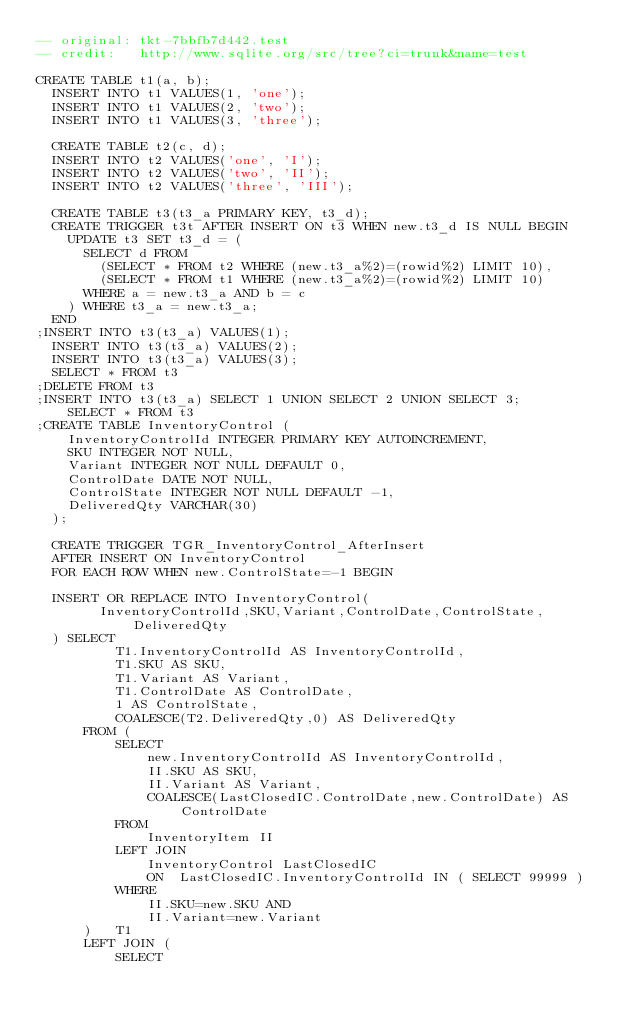<code> <loc_0><loc_0><loc_500><loc_500><_SQL_>-- original: tkt-7bbfb7d442.test
-- credit:   http://www.sqlite.org/src/tree?ci=trunk&name=test

CREATE TABLE t1(a, b);
  INSERT INTO t1 VALUES(1, 'one');
  INSERT INTO t1 VALUES(2, 'two');
  INSERT INTO t1 VALUES(3, 'three');

  CREATE TABLE t2(c, d);
  INSERT INTO t2 VALUES('one', 'I');
  INSERT INTO t2 VALUES('two', 'II');
  INSERT INTO t2 VALUES('three', 'III');

  CREATE TABLE t3(t3_a PRIMARY KEY, t3_d);
  CREATE TRIGGER t3t AFTER INSERT ON t3 WHEN new.t3_d IS NULL BEGIN
    UPDATE t3 SET t3_d = (
      SELECT d FROM 
        (SELECT * FROM t2 WHERE (new.t3_a%2)=(rowid%2) LIMIT 10),
        (SELECT * FROM t1 WHERE (new.t3_a%2)=(rowid%2) LIMIT 10)
      WHERE a = new.t3_a AND b = c
    ) WHERE t3_a = new.t3_a;
  END
;INSERT INTO t3(t3_a) VALUES(1);
  INSERT INTO t3(t3_a) VALUES(2);
  INSERT INTO t3(t3_a) VALUES(3);
  SELECT * FROM t3
;DELETE FROM t3
;INSERT INTO t3(t3_a) SELECT 1 UNION SELECT 2 UNION SELECT 3;
    SELECT * FROM t3
;CREATE TABLE InventoryControl (
    InventoryControlId INTEGER PRIMARY KEY AUTOINCREMENT,
    SKU INTEGER NOT NULL,
    Variant INTEGER NOT NULL DEFAULT 0,
    ControlDate DATE NOT NULL,
    ControlState INTEGER NOT NULL DEFAULT -1,
    DeliveredQty VARCHAR(30)
  );
  
  CREATE TRIGGER TGR_InventoryControl_AfterInsert
  AFTER INSERT ON InventoryControl 
  FOR EACH ROW WHEN new.ControlState=-1 BEGIN 

  INSERT OR REPLACE INTO InventoryControl(
        InventoryControlId,SKU,Variant,ControlDate,ControlState,DeliveredQty
  ) SELECT
          T1.InventoryControlId AS InventoryControlId,
          T1.SKU AS SKU,
          T1.Variant AS Variant,
          T1.ControlDate AS ControlDate,
          1 AS ControlState,
          COALESCE(T2.DeliveredQty,0) AS DeliveredQty
      FROM (
          SELECT
              new.InventoryControlId AS InventoryControlId,
              II.SKU AS SKU,
              II.Variant AS Variant,
              COALESCE(LastClosedIC.ControlDate,new.ControlDate) AS ControlDate
          FROM
              InventoryItem II
          LEFT JOIN
              InventoryControl LastClosedIC
              ON  LastClosedIC.InventoryControlId IN ( SELECT 99999 )
          WHERE
              II.SKU=new.SKU AND
              II.Variant=new.Variant
      )   T1
      LEFT JOIN (
          SELECT</code> 